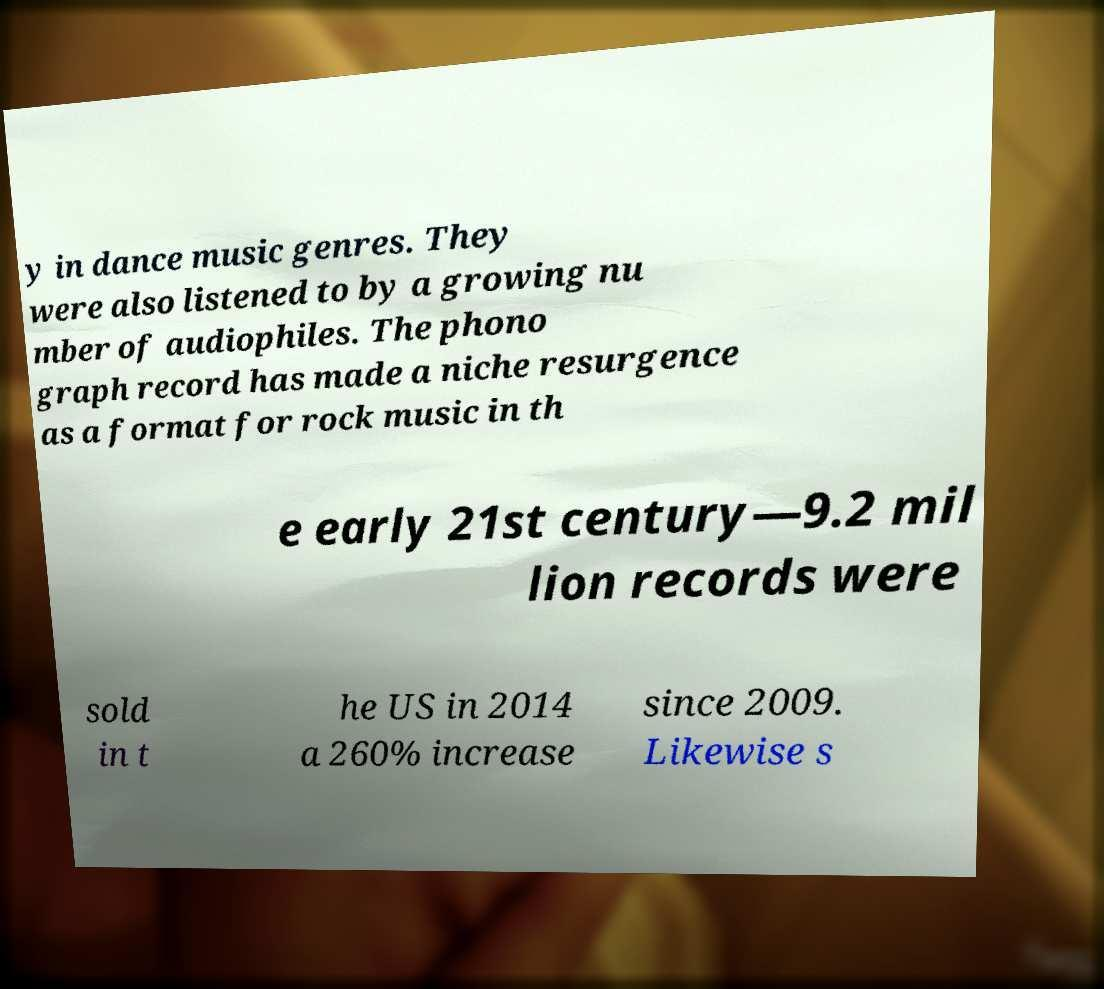Could you assist in decoding the text presented in this image and type it out clearly? y in dance music genres. They were also listened to by a growing nu mber of audiophiles. The phono graph record has made a niche resurgence as a format for rock music in th e early 21st century—9.2 mil lion records were sold in t he US in 2014 a 260% increase since 2009. Likewise s 